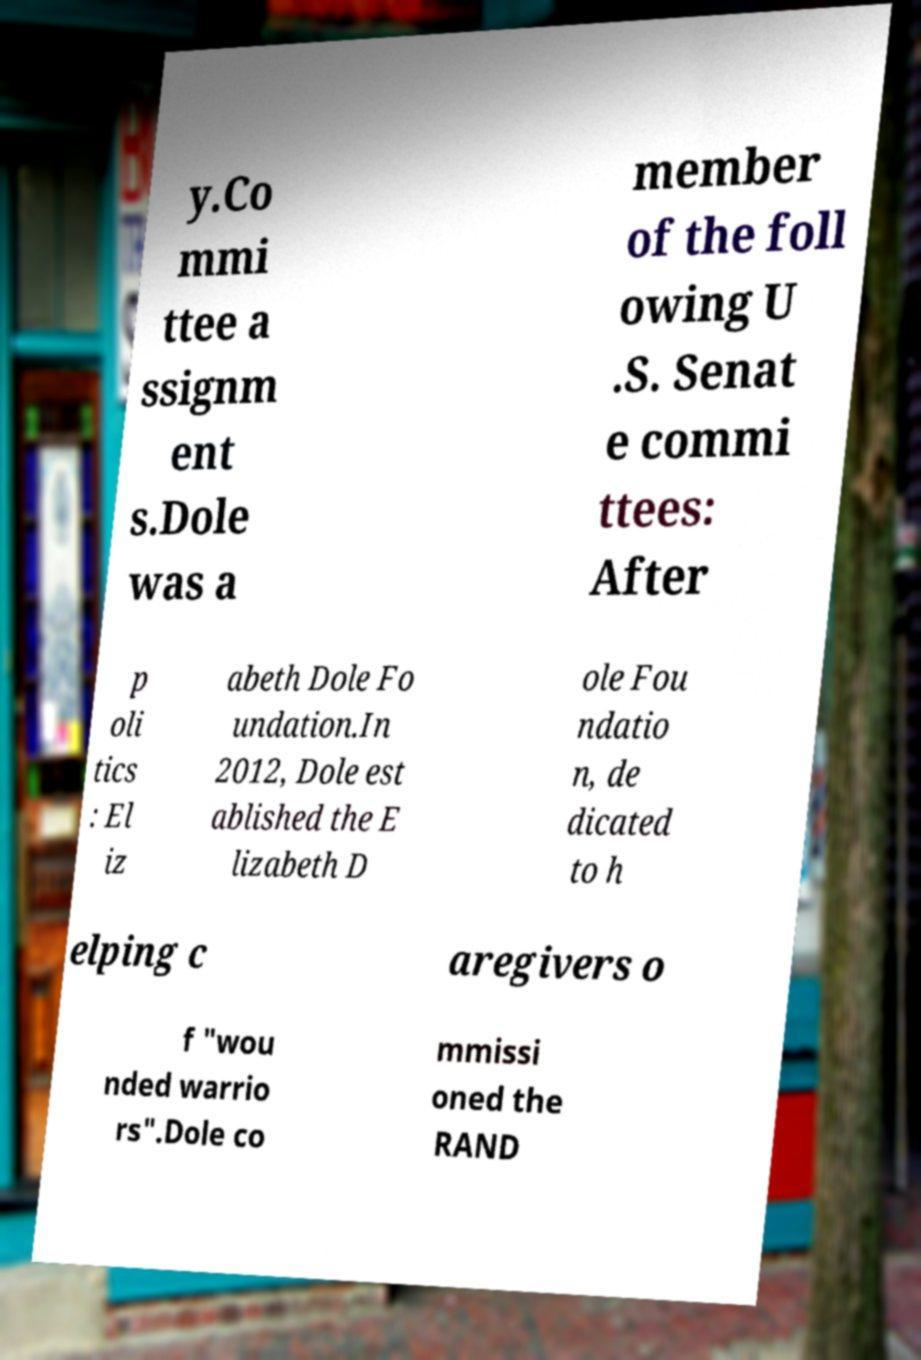Please identify and transcribe the text found in this image. y.Co mmi ttee a ssignm ent s.Dole was a member of the foll owing U .S. Senat e commi ttees: After p oli tics : El iz abeth Dole Fo undation.In 2012, Dole est ablished the E lizabeth D ole Fou ndatio n, de dicated to h elping c aregivers o f "wou nded warrio rs".Dole co mmissi oned the RAND 